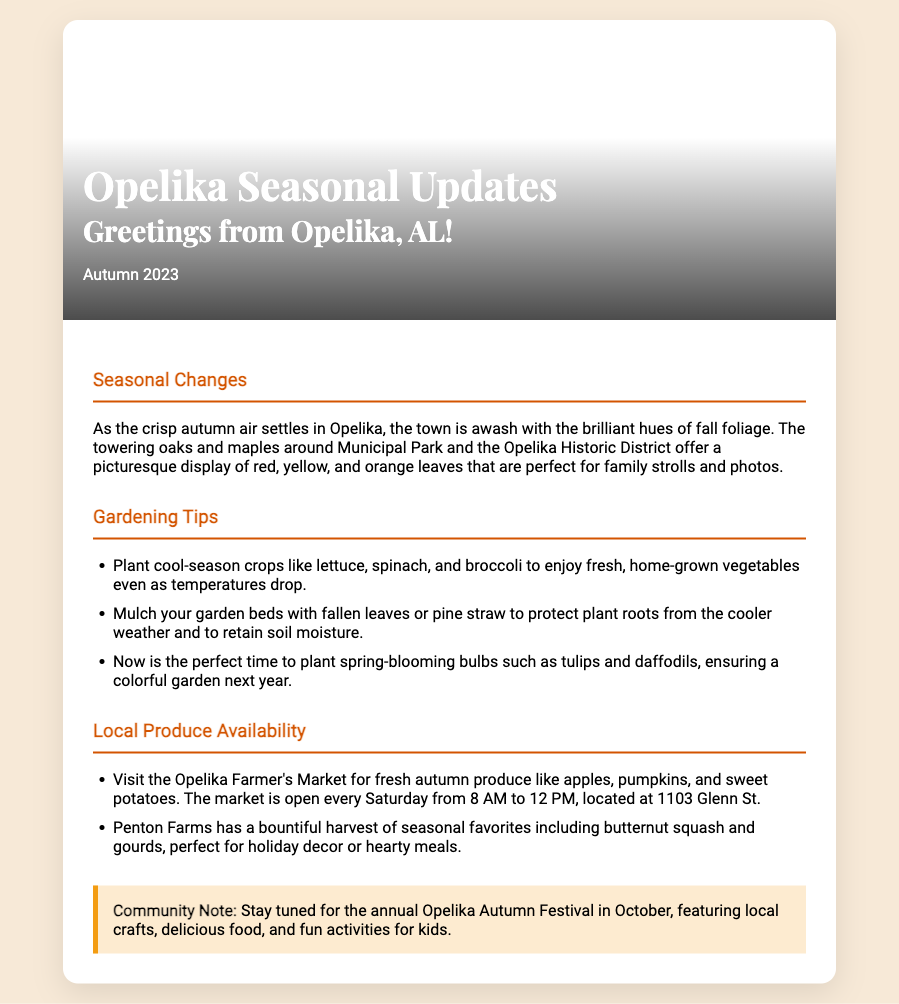what season is highlighted in the card? The card specifically mentions that it is highlighting "Autumn 2023".
Answer: Autumn 2023 what local market is mentioned for fresh produce? The document refers to "Opelika Farmer's Market", which is noted for its availability of fresh produce.
Answer: Opelika Farmer's Market when is the Opelika Farmer's Market open? The document specifies that the market is open every Saturday from 8 AM to 12 PM.
Answer: Saturday from 8 AM to 12 PM what is one gardening tip mentioned? The document lists several gardening tips, one being to "plant cool-season crops like lettuce, spinach, and broccoli".
Answer: plant cool-season crops which local farm has a harvest of butternut squash? The document refers to "Penton Farms" as having a bountiful harvest of seasonal favorites, including butternut squash.
Answer: Penton Farms what natural event is this card likely to encourage? The seasonal updates card includes information about the "annual Opelika Autumn Festival", which is an event for the community.
Answer: annual Opelika Autumn Festival what type of crops should be planted to enjoy fresh vegetables as temperatures drop? The card suggests planting "cool-season crops" like lettuce, spinach, and broccoli.
Answer: cool-season crops what colors dominate the autumn foliage mentioned in the document? The document describes the autumn leaves with hues of red, yellow, and orange.
Answer: red, yellow, and orange 